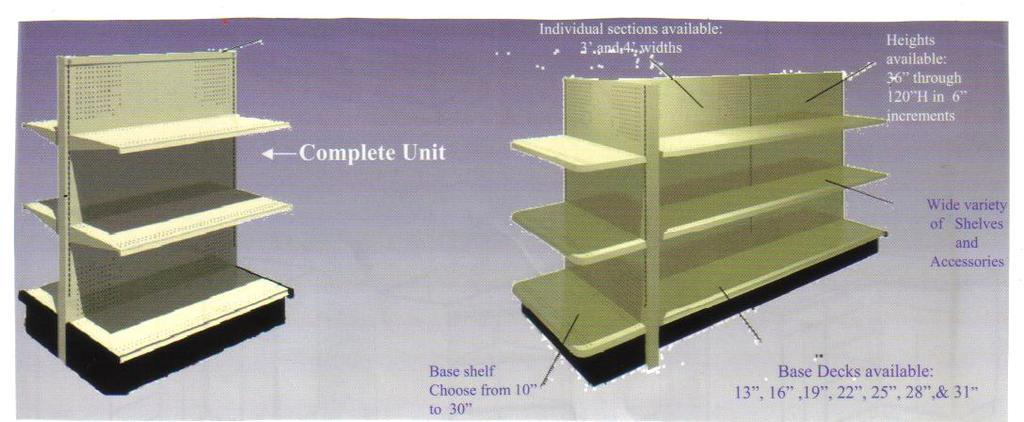Provide a one-sentence caption for the provided image. A complete shelving unit and a second with dimensions and options are shown. 